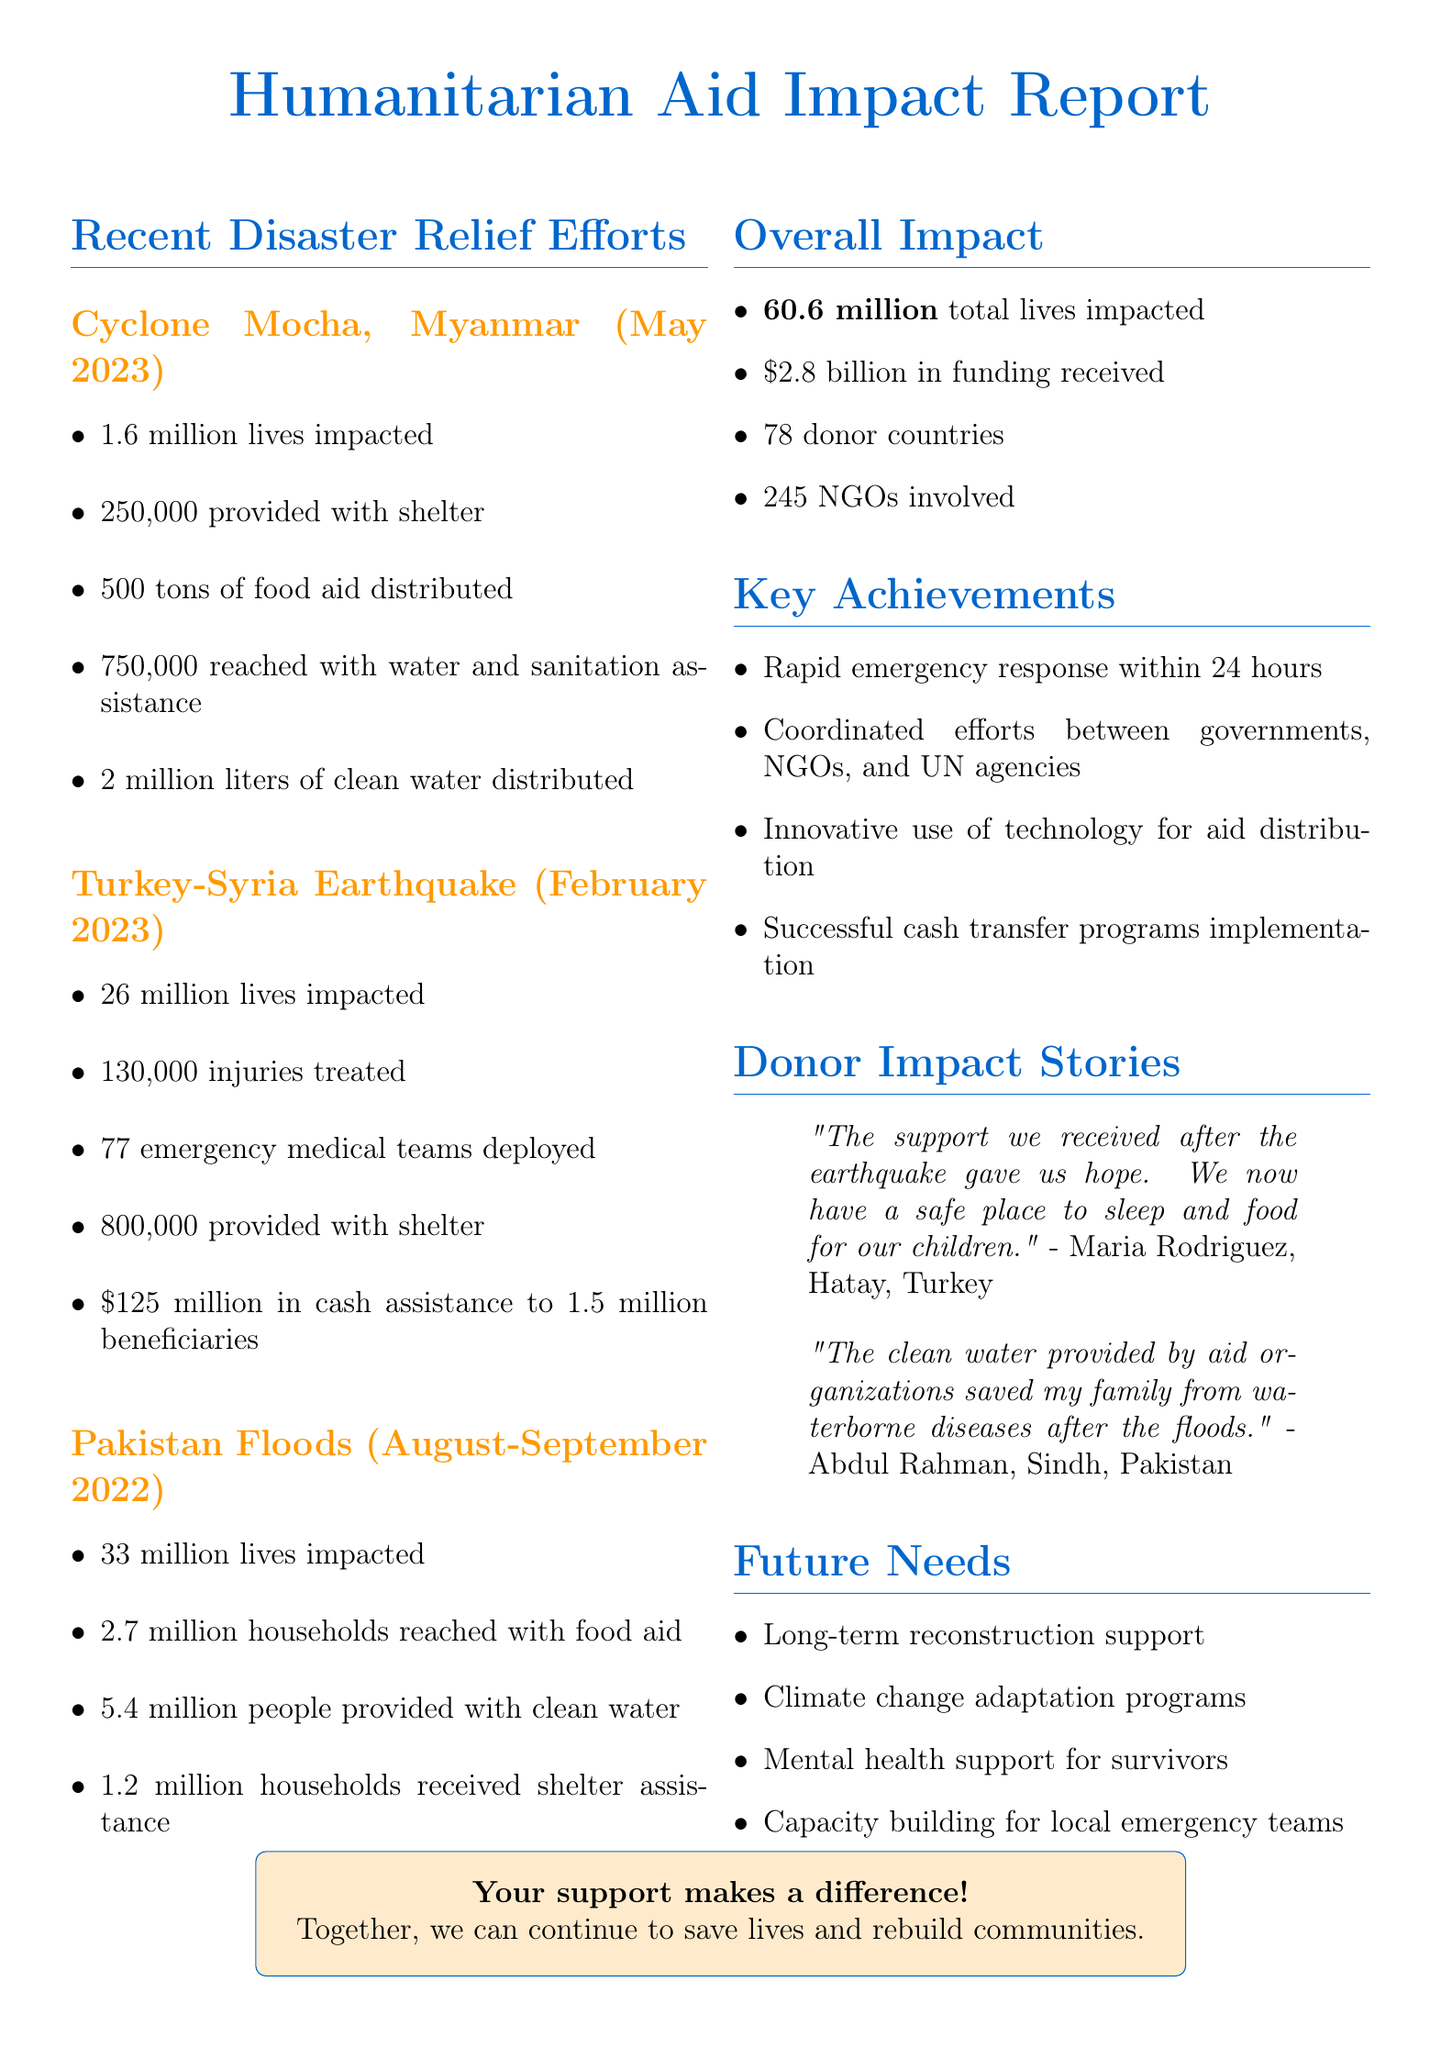What is the total number of lives impacted by all disasters? The total number of lives impacted is the sum of lives impacted from each disaster, which amounts to 60.6 million.
Answer: 60.6 million How many households received shelter assistance during the Pakistan Floods? The document states that 1.2 million households received shelter assistance.
Answer: 1.2 million What is the clean water distributed in liters during Cyclone Mocha? The document mentions that 2 million liters of clean water were distributed in Cyclone Mocha.
Answer: 2 million liters How many emergency medical teams were deployed during the Turkey-Syria Earthquake? The document lists that 77 emergency medical teams were deployed during the Turkey-Syria Earthquake.
Answer: 77 What kind of support is needed for the survivors in the future? The document emphasizes future needs, including mental health and psychosocial support for survivors.
Answer: Mental health and psychosocial support What was the amount of cash assistance provided in the Turkey-Syria Earthquake? The document indicates that $125 million was provided in cash assistance.
Answer: 125 million USD How many donor countries were involved in the overall humanitarian efforts? The document states that there were 78 donor countries involved.
Answer: 78 What was one key achievement mentioned in the document? The document highlights rapid emergency response within 24 hours of each disaster as a key achievement.
Answer: Rapid emergency response within 24 hours 